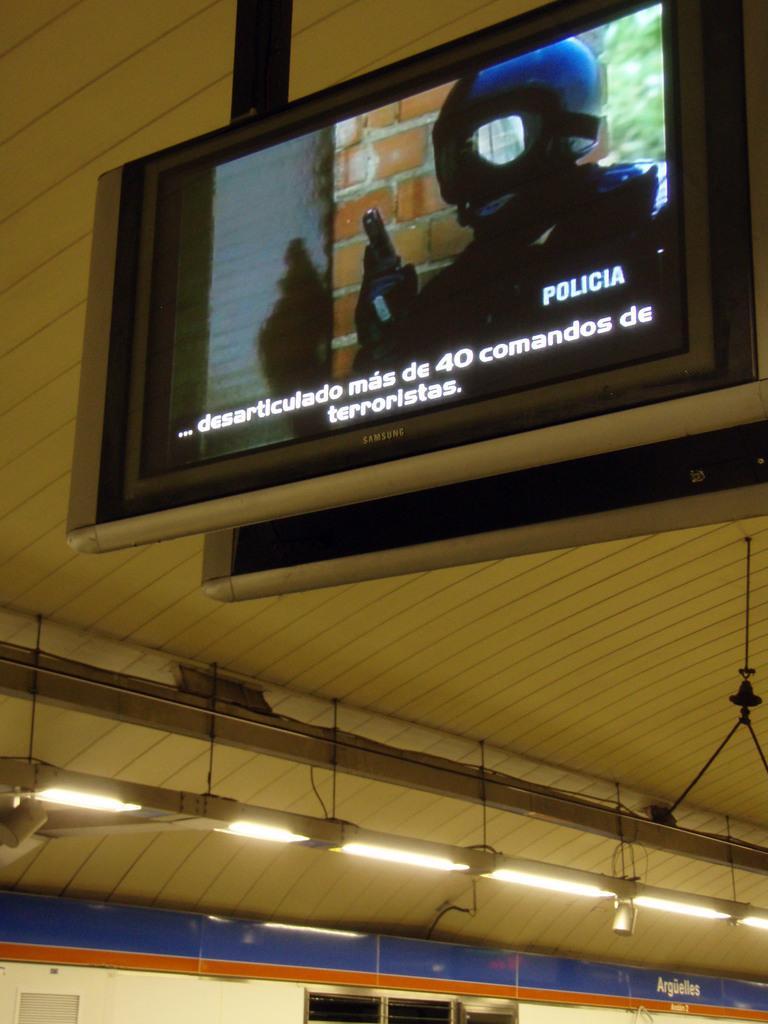How would you summarize this image in a sentence or two? As we can see in the image there is a screen, lights, wall and in screen there is a man wearing helmet and holding pistol. 